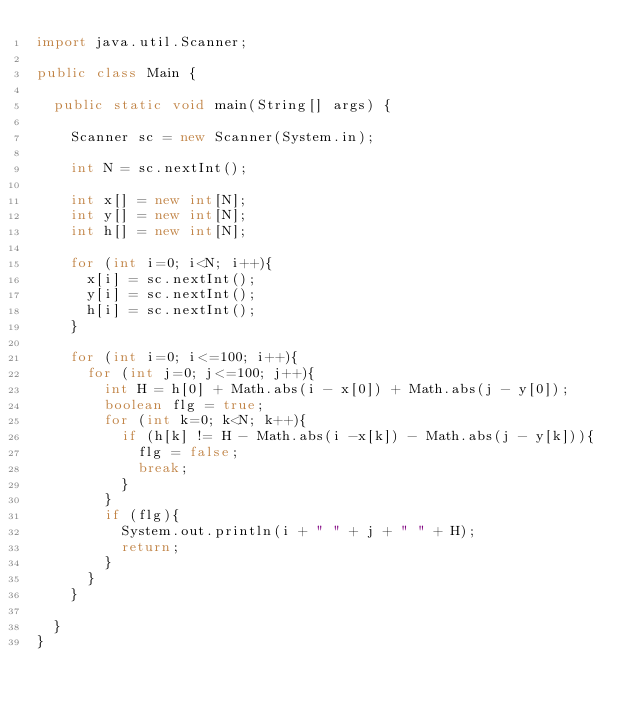<code> <loc_0><loc_0><loc_500><loc_500><_Java_>import java.util.Scanner;

public class Main {

	public static void main(String[] args) {

		Scanner sc = new Scanner(System.in);

		int N = sc.nextInt();

		int x[] = new int[N];
		int y[] = new int[N];
		int h[] = new int[N];

		for (int i=0; i<N; i++){
			x[i] = sc.nextInt();
			y[i] = sc.nextInt();
			h[i] = sc.nextInt();
		}

		for (int i=0; i<=100; i++){
			for (int j=0; j<=100; j++){
				int H = h[0] + Math.abs(i - x[0]) + Math.abs(j - y[0]);
				boolean flg = true;
				for (int k=0; k<N; k++){
					if (h[k] != H - Math.abs(i -x[k]) - Math.abs(j - y[k])){
						flg = false;
						break;
					}
				}
				if (flg){
					System.out.println(i + " " + j + " " + H);
					return;
				}
			}
		}

	}
}</code> 